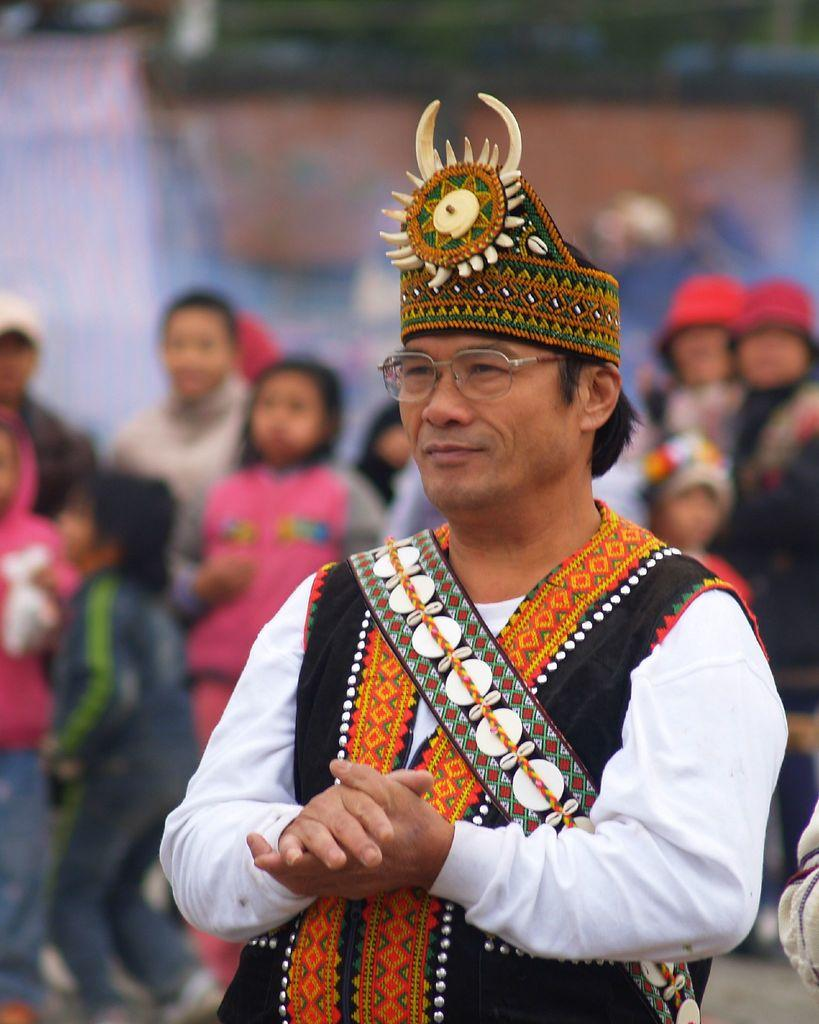What is the main subject of the image? The main subject of the image is a man standing in the middle. What is the man doing in the image? The man is smiling in the image. Are there any other people in the image? Yes, there are people standing behind the man. Can you describe the background of the image? The background of the image is blurred. What direction is the drum facing in the image? There is no drum present in the image. Is there a cactus visible in the background of the image? No, there is no cactus visible in the image. 